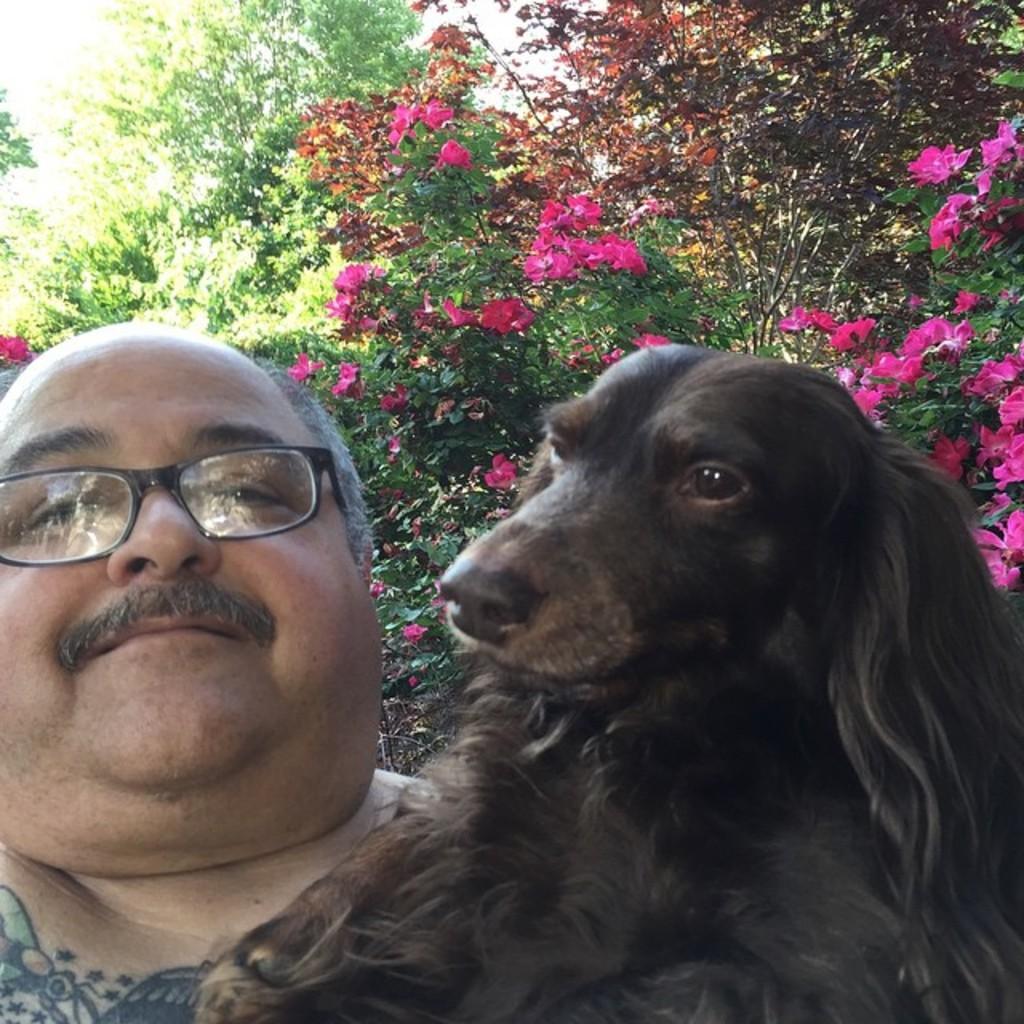In one or two sentences, can you explain what this image depicts? In the image we can see there is a man who is holding a dog in his hand and the dog is in black colour and at the back there are plants on which there are pink colour flowers. 